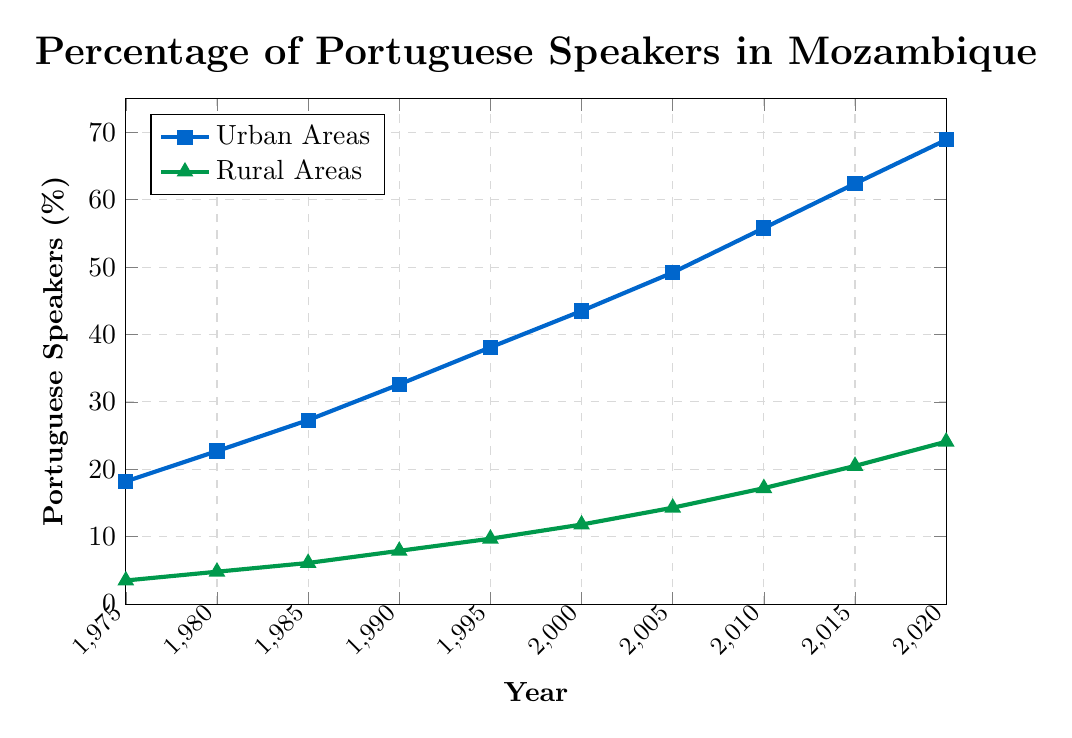What's the trend of Portuguese speakers over time in both urban and rural areas? Both the percentage of Portuguese speakers in urban and rural areas consistently increases from 1975 to 2020. In urban areas, the percentage starts at 18.2% in 1975 and reaches 68.9% in 2020. In rural areas, it starts at 3.5% in 1975 and climbs to 24.1% in 2020.
Answer: Increasing trend in both areas In which year did the urban Portuguese speakers surpass 50%? We need to look for the first year in the urban data series where the percentage exceeds 50%. The urban percentage surpasses 50% in 2005 when it reaches 49.2% and then 55.8% in 2010.
Answer: 2010 What is the difference in the percentage of Portuguese speakers between urban and rural areas in 1990? To find the difference, subtract the rural percentage from the urban percentage for the year 1990. This is 32.6% (urban) - 7.9% (rural) = 24.7%.
Answer: 24.7% On average, by how much do urban Portuguese speakers increase every 5 years? Calculating the 5-year increases: (22.7-18.2), (27.3-22.7), (32.6-27.3), (38.1-32.6), (43.5-38.1), (49.2-43.5), (55.8-49.2), (62.4-55.8), (68.9-62.4). Summing them gives a total increase of 50.7 over 9 periods. The average is 50.7 / 9 = 5.63%.
Answer: 5.63% In which year was the gap between urban and rural Portuguese speakers the widest? The widest gap is found by looking for the greatest difference between the respective years' percentages. The widest gap occurs in 2020 with urban at 68.9% and rural at 24.1%, making the difference 44.8%.
Answer: 2020 Which year shows the smallest increase for urban Portuguese speakers? Identifying the smallest increase requires comparing the year-to-year differences: (22.7-18.2), (27.3-22.7), (32.6-27.3), (38.1-32.6), (43.5-38.1), (49.2-43.5), (55.8-49.2), (62.4-55.8), (68.9-62.4). The smallest difference is 5.4% (1985-1980).
Answer: 1985 By how much did the percentage of rural Portuguese speakers grow from 2000 to 2020? Subtract the percentage of rural speakers in 2000 from that in 2020. So, it is 24.1% (2020) - 11.8% (2000) = 12.3%.
Answer: 12.3% What visual difference is used to distinguish urban and rural Portuguese speaker data? The urban Portuguese speaker data is represented using blue color with square markers, while the rural data uses green color with triangle markers.
Answer: Different colors and markers Which area had a faster rate of increase in Portuguese speakers from 2010 to 2020? By calculating the rate of increase: Urban (68.9 - 55.8) = 13.1%, Rural (24.1 - 17.2) = 6.9%. The urban areas had a faster rate of increase.
Answer: Urban areas What was the percentage of Portuguese speakers in urban areas by the end of the period? At the end of the period in 2020, urban areas had 68.9% Portuguese speakers.
Answer: 68.9% 